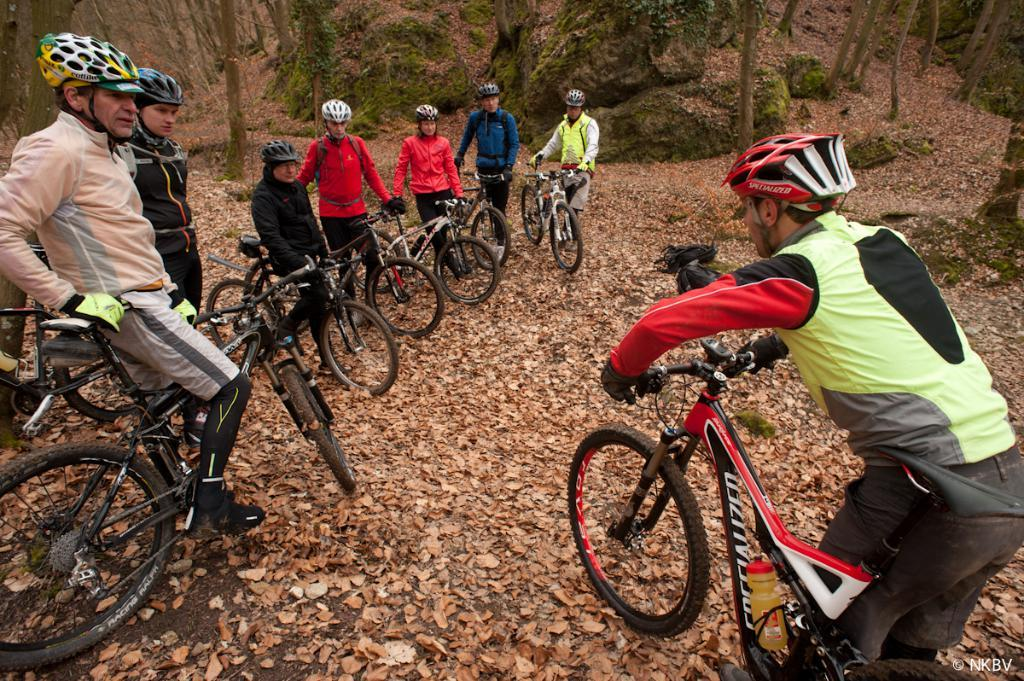What are the people in the image wearing on their heads? The people in the image are wearing helmets. What are the people holding in the image? The people are holding cycles. What type of natural environment can be seen in the image? There are trees visible in the image. What is present on the ground in the image? Leafs are present on the ground in the image. Can you see someone's finger in the image? There is no visible finger in the image. What type of ear is present in the image? There is no ear present in the image. 